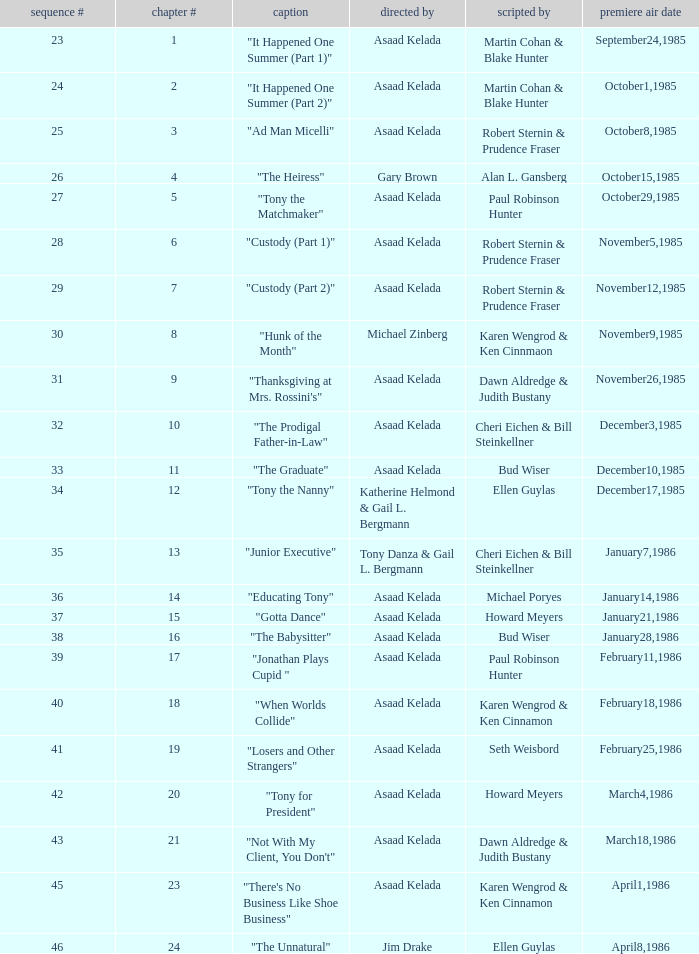Who were the authors of series episode #25? Robert Sternin & Prudence Fraser. 